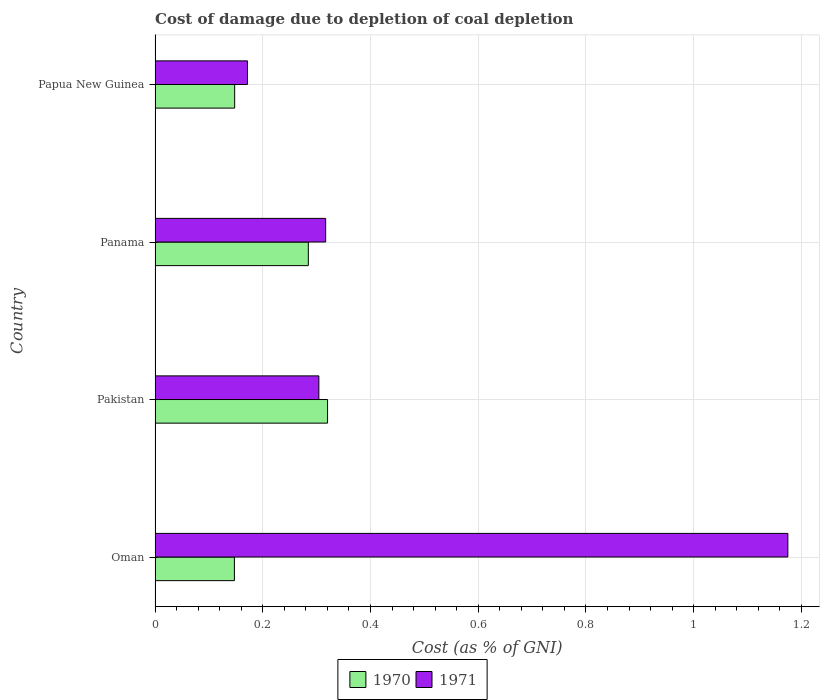Are the number of bars on each tick of the Y-axis equal?
Your response must be concise. Yes. How many bars are there on the 3rd tick from the bottom?
Provide a short and direct response. 2. What is the label of the 2nd group of bars from the top?
Offer a terse response. Panama. What is the cost of damage caused due to coal depletion in 1971 in Oman?
Provide a short and direct response. 1.17. Across all countries, what is the maximum cost of damage caused due to coal depletion in 1970?
Your response must be concise. 0.32. Across all countries, what is the minimum cost of damage caused due to coal depletion in 1971?
Give a very brief answer. 0.17. In which country was the cost of damage caused due to coal depletion in 1971 minimum?
Offer a terse response. Papua New Guinea. What is the total cost of damage caused due to coal depletion in 1971 in the graph?
Ensure brevity in your answer.  1.97. What is the difference between the cost of damage caused due to coal depletion in 1970 in Panama and that in Papua New Guinea?
Your answer should be very brief. 0.14. What is the difference between the cost of damage caused due to coal depletion in 1970 in Panama and the cost of damage caused due to coal depletion in 1971 in Oman?
Your response must be concise. -0.89. What is the average cost of damage caused due to coal depletion in 1971 per country?
Give a very brief answer. 0.49. What is the difference between the cost of damage caused due to coal depletion in 1971 and cost of damage caused due to coal depletion in 1970 in Papua New Guinea?
Keep it short and to the point. 0.02. In how many countries, is the cost of damage caused due to coal depletion in 1970 greater than 0.2 %?
Ensure brevity in your answer.  2. What is the ratio of the cost of damage caused due to coal depletion in 1971 in Oman to that in Panama?
Provide a short and direct response. 3.71. Is the cost of damage caused due to coal depletion in 1971 in Oman less than that in Papua New Guinea?
Give a very brief answer. No. Is the difference between the cost of damage caused due to coal depletion in 1971 in Oman and Pakistan greater than the difference between the cost of damage caused due to coal depletion in 1970 in Oman and Pakistan?
Offer a terse response. Yes. What is the difference between the highest and the second highest cost of damage caused due to coal depletion in 1971?
Provide a short and direct response. 0.86. What is the difference between the highest and the lowest cost of damage caused due to coal depletion in 1970?
Your response must be concise. 0.17. Is the sum of the cost of damage caused due to coal depletion in 1971 in Pakistan and Panama greater than the maximum cost of damage caused due to coal depletion in 1970 across all countries?
Offer a terse response. Yes. What does the 2nd bar from the top in Panama represents?
Keep it short and to the point. 1970. What is the difference between two consecutive major ticks on the X-axis?
Ensure brevity in your answer.  0.2. Where does the legend appear in the graph?
Provide a short and direct response. Bottom center. What is the title of the graph?
Offer a terse response. Cost of damage due to depletion of coal depletion. Does "1968" appear as one of the legend labels in the graph?
Your answer should be compact. No. What is the label or title of the X-axis?
Your answer should be compact. Cost (as % of GNI). What is the label or title of the Y-axis?
Ensure brevity in your answer.  Country. What is the Cost (as % of GNI) of 1970 in Oman?
Ensure brevity in your answer.  0.15. What is the Cost (as % of GNI) in 1971 in Oman?
Provide a succinct answer. 1.17. What is the Cost (as % of GNI) in 1970 in Pakistan?
Provide a short and direct response. 0.32. What is the Cost (as % of GNI) of 1971 in Pakistan?
Your answer should be compact. 0.3. What is the Cost (as % of GNI) in 1970 in Panama?
Ensure brevity in your answer.  0.28. What is the Cost (as % of GNI) of 1971 in Panama?
Your response must be concise. 0.32. What is the Cost (as % of GNI) of 1970 in Papua New Guinea?
Give a very brief answer. 0.15. What is the Cost (as % of GNI) in 1971 in Papua New Guinea?
Ensure brevity in your answer.  0.17. Across all countries, what is the maximum Cost (as % of GNI) of 1970?
Your response must be concise. 0.32. Across all countries, what is the maximum Cost (as % of GNI) of 1971?
Your answer should be compact. 1.17. Across all countries, what is the minimum Cost (as % of GNI) of 1970?
Give a very brief answer. 0.15. Across all countries, what is the minimum Cost (as % of GNI) of 1971?
Offer a very short reply. 0.17. What is the total Cost (as % of GNI) in 1970 in the graph?
Give a very brief answer. 0.9. What is the total Cost (as % of GNI) of 1971 in the graph?
Offer a very short reply. 1.97. What is the difference between the Cost (as % of GNI) in 1970 in Oman and that in Pakistan?
Your response must be concise. -0.17. What is the difference between the Cost (as % of GNI) of 1971 in Oman and that in Pakistan?
Your answer should be very brief. 0.87. What is the difference between the Cost (as % of GNI) in 1970 in Oman and that in Panama?
Ensure brevity in your answer.  -0.14. What is the difference between the Cost (as % of GNI) of 1971 in Oman and that in Panama?
Ensure brevity in your answer.  0.86. What is the difference between the Cost (as % of GNI) in 1970 in Oman and that in Papua New Guinea?
Offer a terse response. -0. What is the difference between the Cost (as % of GNI) in 1971 in Oman and that in Papua New Guinea?
Offer a terse response. 1. What is the difference between the Cost (as % of GNI) of 1970 in Pakistan and that in Panama?
Your response must be concise. 0.04. What is the difference between the Cost (as % of GNI) in 1971 in Pakistan and that in Panama?
Your response must be concise. -0.01. What is the difference between the Cost (as % of GNI) of 1970 in Pakistan and that in Papua New Guinea?
Offer a very short reply. 0.17. What is the difference between the Cost (as % of GNI) of 1971 in Pakistan and that in Papua New Guinea?
Offer a terse response. 0.13. What is the difference between the Cost (as % of GNI) in 1970 in Panama and that in Papua New Guinea?
Keep it short and to the point. 0.14. What is the difference between the Cost (as % of GNI) in 1971 in Panama and that in Papua New Guinea?
Give a very brief answer. 0.15. What is the difference between the Cost (as % of GNI) in 1970 in Oman and the Cost (as % of GNI) in 1971 in Pakistan?
Provide a succinct answer. -0.16. What is the difference between the Cost (as % of GNI) in 1970 in Oman and the Cost (as % of GNI) in 1971 in Panama?
Offer a very short reply. -0.17. What is the difference between the Cost (as % of GNI) of 1970 in Oman and the Cost (as % of GNI) of 1971 in Papua New Guinea?
Provide a succinct answer. -0.02. What is the difference between the Cost (as % of GNI) of 1970 in Pakistan and the Cost (as % of GNI) of 1971 in Panama?
Provide a short and direct response. 0. What is the difference between the Cost (as % of GNI) of 1970 in Pakistan and the Cost (as % of GNI) of 1971 in Papua New Guinea?
Keep it short and to the point. 0.15. What is the difference between the Cost (as % of GNI) in 1970 in Panama and the Cost (as % of GNI) in 1971 in Papua New Guinea?
Your answer should be compact. 0.11. What is the average Cost (as % of GNI) of 1970 per country?
Offer a very short reply. 0.23. What is the average Cost (as % of GNI) of 1971 per country?
Your answer should be compact. 0.49. What is the difference between the Cost (as % of GNI) in 1970 and Cost (as % of GNI) in 1971 in Oman?
Your answer should be very brief. -1.03. What is the difference between the Cost (as % of GNI) in 1970 and Cost (as % of GNI) in 1971 in Pakistan?
Your response must be concise. 0.02. What is the difference between the Cost (as % of GNI) in 1970 and Cost (as % of GNI) in 1971 in Panama?
Keep it short and to the point. -0.03. What is the difference between the Cost (as % of GNI) of 1970 and Cost (as % of GNI) of 1971 in Papua New Guinea?
Make the answer very short. -0.02. What is the ratio of the Cost (as % of GNI) in 1970 in Oman to that in Pakistan?
Offer a very short reply. 0.46. What is the ratio of the Cost (as % of GNI) of 1971 in Oman to that in Pakistan?
Offer a terse response. 3.86. What is the ratio of the Cost (as % of GNI) of 1970 in Oman to that in Panama?
Provide a succinct answer. 0.52. What is the ratio of the Cost (as % of GNI) in 1971 in Oman to that in Panama?
Give a very brief answer. 3.71. What is the ratio of the Cost (as % of GNI) in 1970 in Oman to that in Papua New Guinea?
Your answer should be very brief. 1. What is the ratio of the Cost (as % of GNI) of 1971 in Oman to that in Papua New Guinea?
Make the answer very short. 6.85. What is the ratio of the Cost (as % of GNI) of 1970 in Pakistan to that in Panama?
Ensure brevity in your answer.  1.13. What is the ratio of the Cost (as % of GNI) of 1971 in Pakistan to that in Panama?
Your answer should be compact. 0.96. What is the ratio of the Cost (as % of GNI) of 1970 in Pakistan to that in Papua New Guinea?
Provide a short and direct response. 2.17. What is the ratio of the Cost (as % of GNI) in 1971 in Pakistan to that in Papua New Guinea?
Ensure brevity in your answer.  1.77. What is the ratio of the Cost (as % of GNI) of 1970 in Panama to that in Papua New Guinea?
Keep it short and to the point. 1.93. What is the ratio of the Cost (as % of GNI) in 1971 in Panama to that in Papua New Guinea?
Ensure brevity in your answer.  1.85. What is the difference between the highest and the second highest Cost (as % of GNI) of 1970?
Provide a succinct answer. 0.04. What is the difference between the highest and the second highest Cost (as % of GNI) of 1971?
Offer a terse response. 0.86. What is the difference between the highest and the lowest Cost (as % of GNI) of 1970?
Provide a short and direct response. 0.17. 